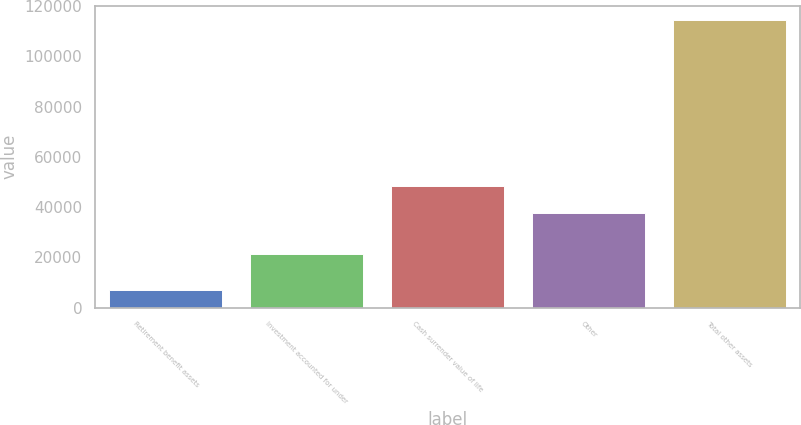Convert chart. <chart><loc_0><loc_0><loc_500><loc_500><bar_chart><fcel>Retirement benefit assets<fcel>Investment accounted for under<fcel>Cash surrender value of life<fcel>Other<fcel>Total other assets<nl><fcel>7229<fcel>21400<fcel>48545.8<fcel>37835<fcel>114337<nl></chart> 